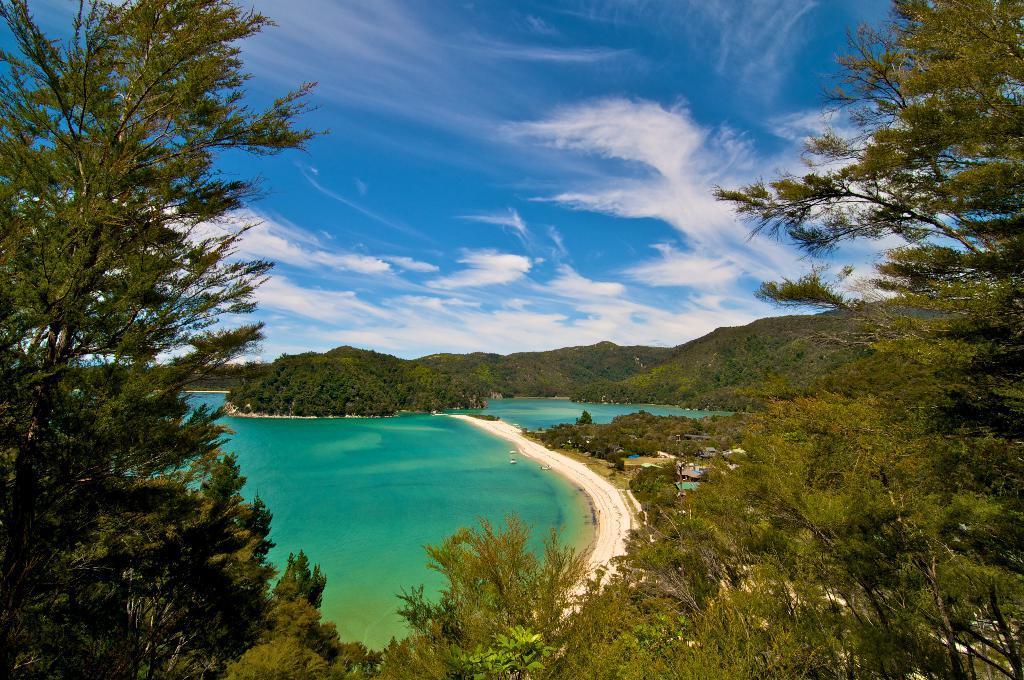In one or two sentences, can you explain what this image depicts? This image is taken outdoors. At the top of the image there is a sky with clouds. In the background there are few hills. There are many trees and plants. In the middle of the image there is the sea and there is a road. On the left and right sides of the image there are many trees and plants with leaves, stems and branches. 